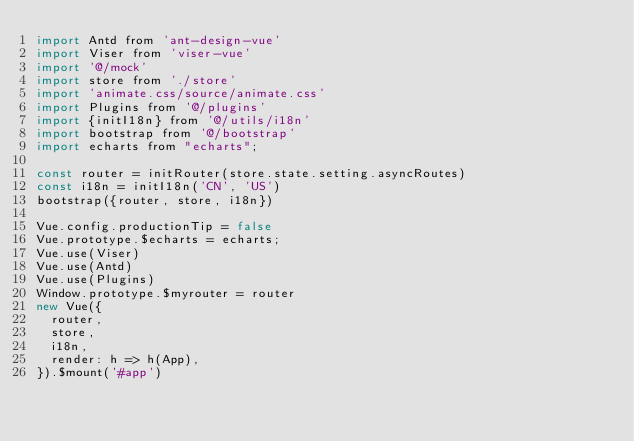<code> <loc_0><loc_0><loc_500><loc_500><_JavaScript_>import Antd from 'ant-design-vue'
import Viser from 'viser-vue'
import '@/mock'
import store from './store'
import 'animate.css/source/animate.css'
import Plugins from '@/plugins'
import {initI18n} from '@/utils/i18n'
import bootstrap from '@/bootstrap'
import echarts from "echarts";

const router = initRouter(store.state.setting.asyncRoutes)
const i18n = initI18n('CN', 'US')
bootstrap({router, store, i18n})

Vue.config.productionTip = false
Vue.prototype.$echarts = echarts;
Vue.use(Viser)
Vue.use(Antd)
Vue.use(Plugins)
Window.prototype.$myrouter = router
new Vue({
  router,
  store,
  i18n,
  render: h => h(App),
}).$mount('#app')
</code> 